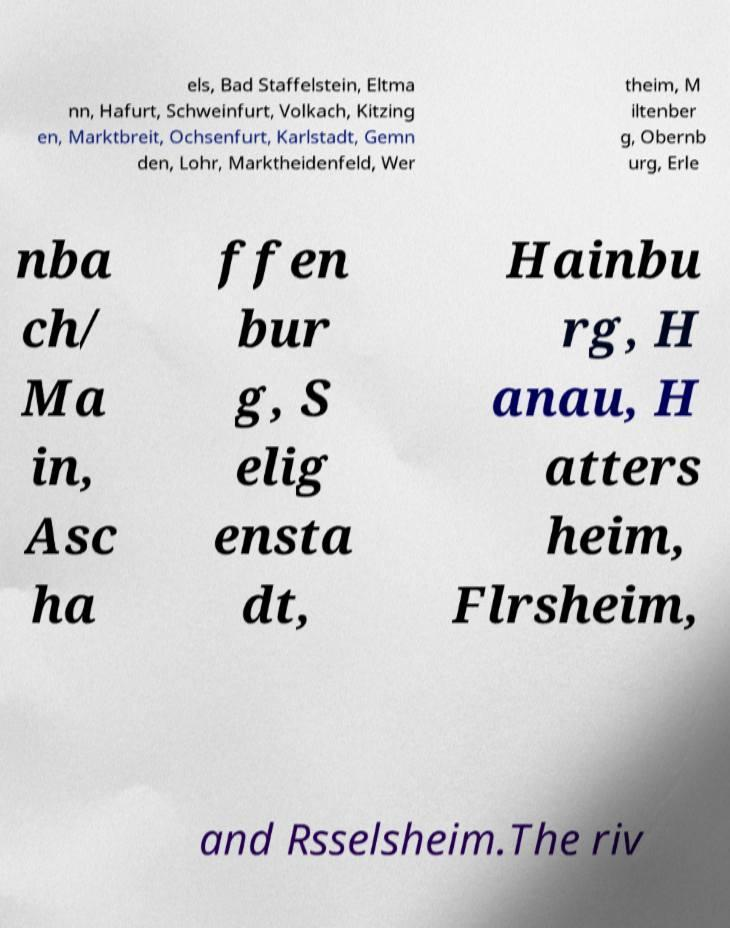For documentation purposes, I need the text within this image transcribed. Could you provide that? els, Bad Staffelstein, Eltma nn, Hafurt, Schweinfurt, Volkach, Kitzing en, Marktbreit, Ochsenfurt, Karlstadt, Gemn den, Lohr, Marktheidenfeld, Wer theim, M iltenber g, Obernb urg, Erle nba ch/ Ma in, Asc ha ffen bur g, S elig ensta dt, Hainbu rg, H anau, H atters heim, Flrsheim, and Rsselsheim.The riv 